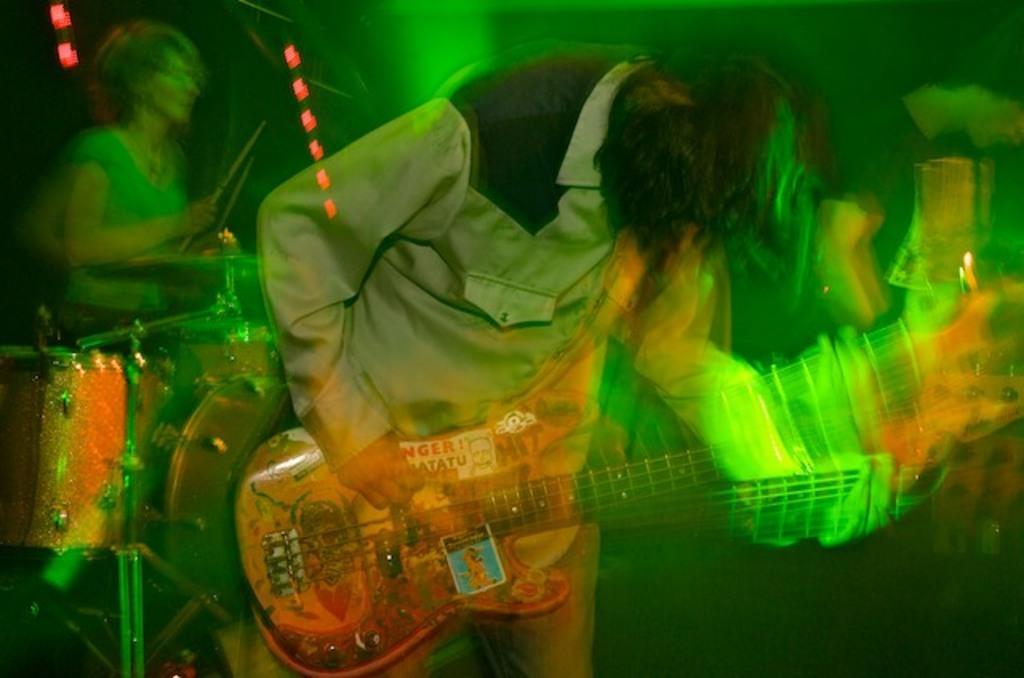In one or two sentences, can you explain what this image depicts? In this image I can see a person holding musical instruments. Background I can see the other person playing drums and I can see few green color lights. 